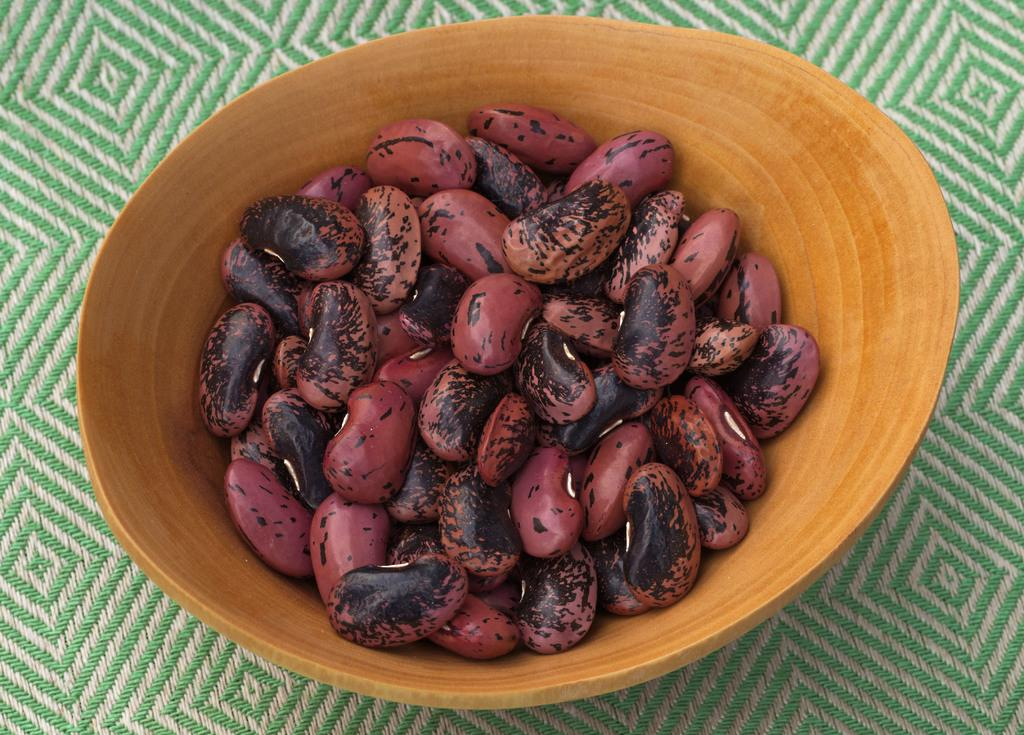What animals are present in the image? There are bears in the image. How are the bears contained or held in the image? The bears are kept inside a wooden cup. Where is the playground located in the image? There is no playground present in the image; it features bears inside a wooden cup. What type of bean is visible in the image? There are no beans present in the image. 